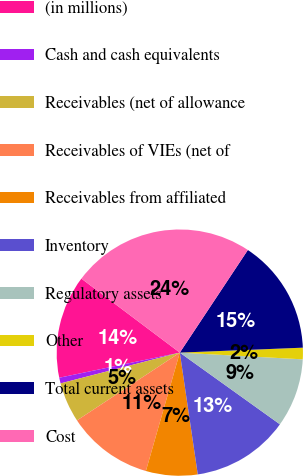Convert chart to OTSL. <chart><loc_0><loc_0><loc_500><loc_500><pie_chart><fcel>(in millions)<fcel>Cash and cash equivalents<fcel>Receivables (net of allowance<fcel>Receivables of VIEs (net of<fcel>Receivables from affiliated<fcel>Inventory<fcel>Regulatory assets<fcel>Other<fcel>Total current assets<fcel>Cost<nl><fcel>13.53%<fcel>0.75%<fcel>5.26%<fcel>11.28%<fcel>6.77%<fcel>12.78%<fcel>9.02%<fcel>1.51%<fcel>15.04%<fcel>24.06%<nl></chart> 